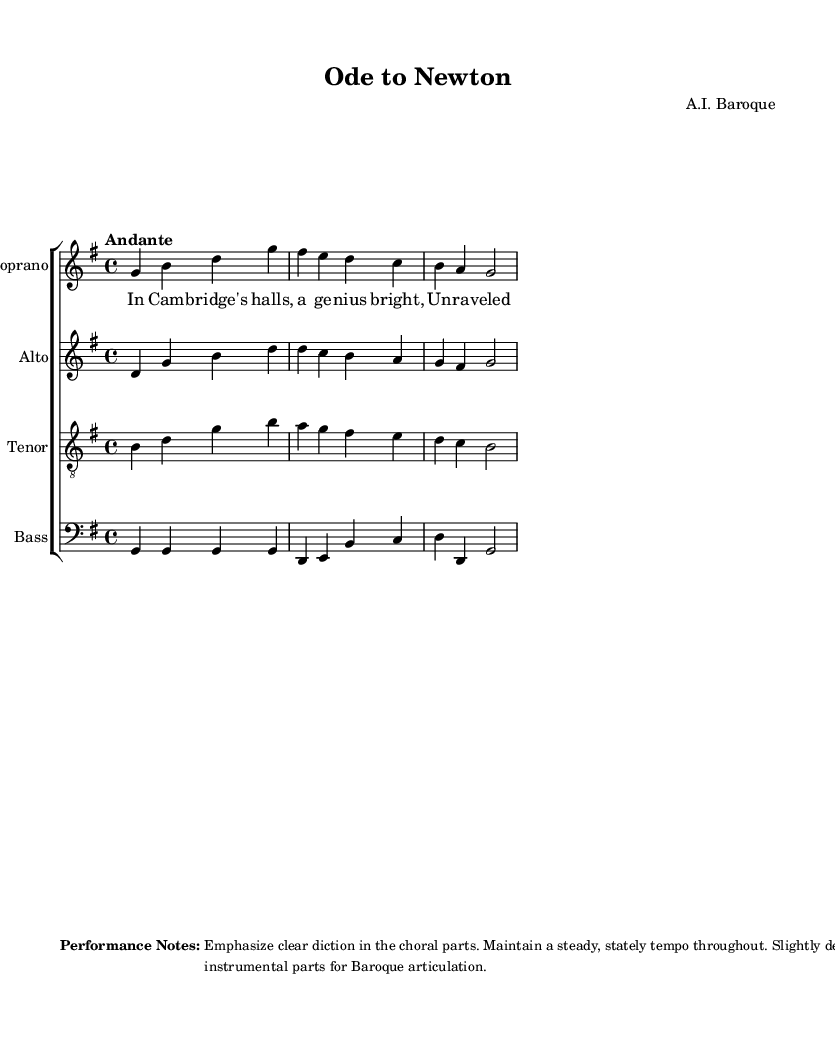What is the key signature of this music? The key signature is G major, which has one sharp (F#). This can be identified at the beginning of the score, where the key signature symbol appears.
Answer: G major What is the time signature of this music? The time signature is 4/4, which means there are four beats in each measure, and the quarter note gets one beat. This can be noted in the first measure of the score, indicated by the "4/4".
Answer: 4/4 What is the tempo marking of this piece? The tempo marking is "Andante", which indicates a moderately slow tempo. This is stated at the beginning of the score, right after the key and time signature.
Answer: Andante How many voices are present in this choral work? There are four voices: soprano, alto, tenor, and bass. This can be seen in the layout of the score, where each voice is assigned to its own staff.
Answer: Four What is the opening note of the soprano voice? The opening note of the soprano voice is G. This can be established by looking at the first note in the soprano line, which corresponds to the first measure's pitch.
Answer: G Which notable figure does the title "Ode to Newton" refer to? The title "Ode to Newton" refers to Sir Isaac Newton, who is a famous scientist known for his laws of motion and gravitation. The title provides direct insight into the thematic focus of the piece, highlighting its tribute to a celebrated scientist.
Answer: Sir Isaac Newton What is the specific musical era represented by this piece? The musical era represented by this piece is the Baroque period, characterized by its use of complex polyphony and emphasis on choral works. This is attributed to the style indicated by the composer and the structure of the piece.
Answer: Baroque 